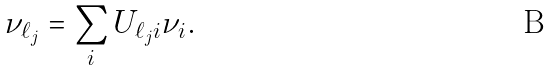<formula> <loc_0><loc_0><loc_500><loc_500>\nu _ { \ell _ { j } } = \sum _ { i } U _ { \ell _ { j } i } \nu _ { i } .</formula> 